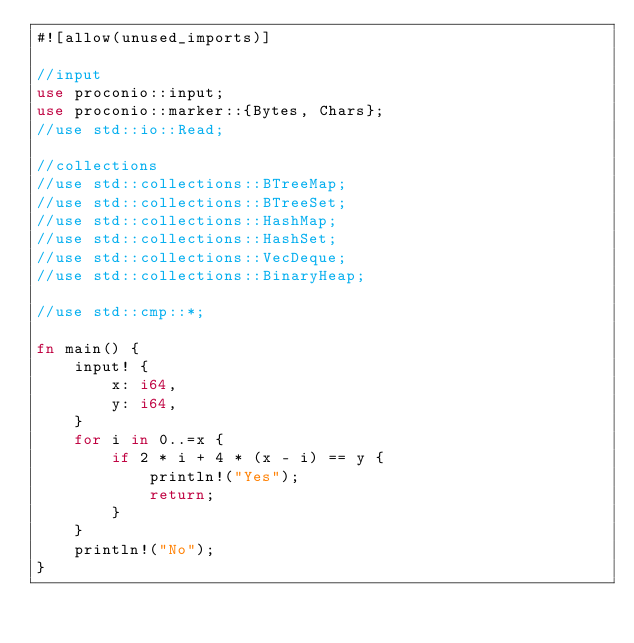Convert code to text. <code><loc_0><loc_0><loc_500><loc_500><_Rust_>#![allow(unused_imports)]

//input
use proconio::input;
use proconio::marker::{Bytes, Chars};
//use std::io::Read;

//collections
//use std::collections::BTreeMap;
//use std::collections::BTreeSet;
//use std::collections::HashMap;
//use std::collections::HashSet;
//use std::collections::VecDeque;
//use std::collections::BinaryHeap;

//use std::cmp::*;

fn main() {
    input! {
        x: i64,
        y: i64,
    }
    for i in 0..=x {
        if 2 * i + 4 * (x - i) == y {
            println!("Yes");
            return;
        }
    }
    println!("No");
}
</code> 